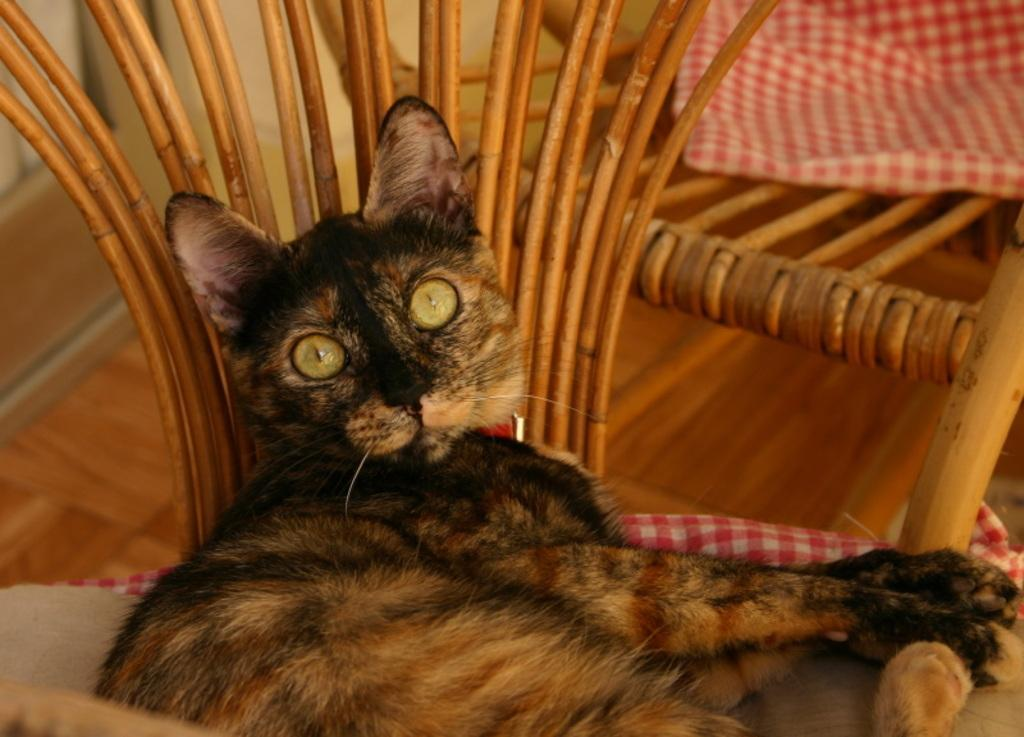What type of animal is in the image? There is a cat in the image. What is the cat doing in the image? The cat is laying on a chair. What type of agreement is being discussed by the cat in the image? There is no indication in the image that the cat is discussing any agreements, as cats do not engage in verbal communication or agreements. 